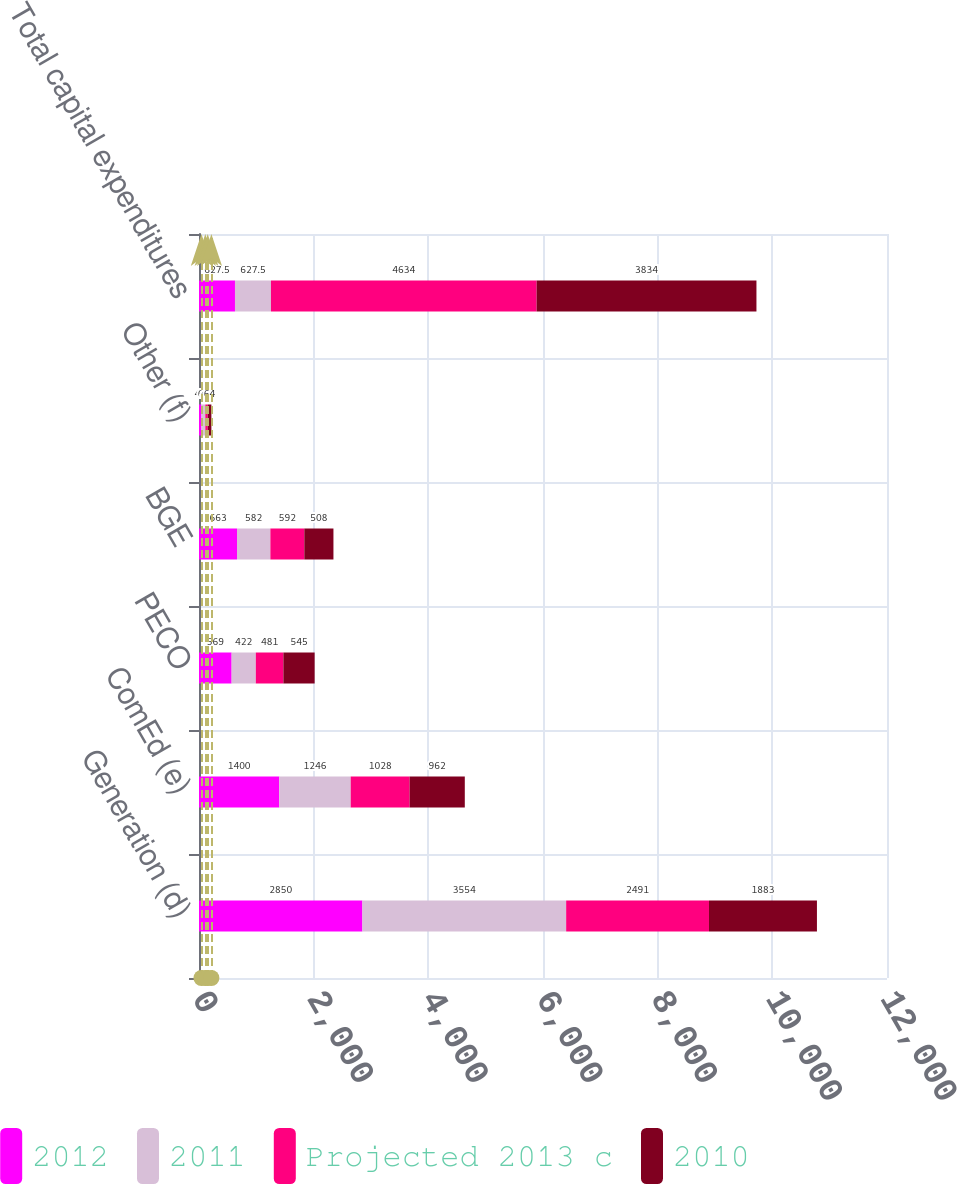<chart> <loc_0><loc_0><loc_500><loc_500><stacked_bar_chart><ecel><fcel>Generation (d)<fcel>ComEd (e)<fcel>PECO<fcel>BGE<fcel>Other (f)<fcel>Total capital expenditures<nl><fcel>2012<fcel>2850<fcel>1400<fcel>569<fcel>663<fcel>43<fcel>627.5<nl><fcel>2011<fcel>3554<fcel>1246<fcel>422<fcel>582<fcel>67<fcel>627.5<nl><fcel>Projected 2013 c<fcel>2491<fcel>1028<fcel>481<fcel>592<fcel>42<fcel>4634<nl><fcel>2010<fcel>1883<fcel>962<fcel>545<fcel>508<fcel>64<fcel>3834<nl></chart> 